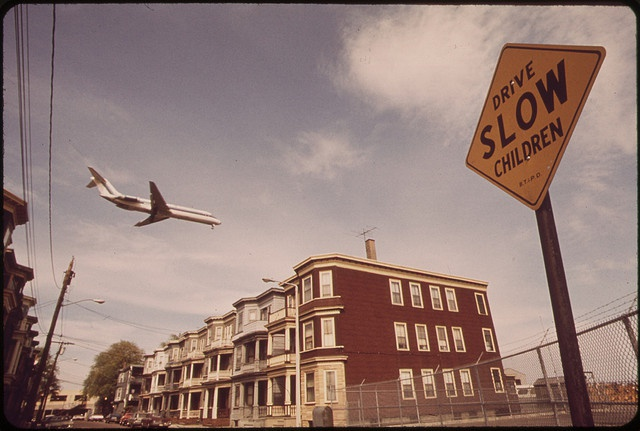Describe the objects in this image and their specific colors. I can see airplane in black, maroon, tan, and brown tones, car in black, maroon, and brown tones, car in black, maroon, gray, and brown tones, car in black, maroon, and brown tones, and car in black, maroon, brown, and gray tones in this image. 